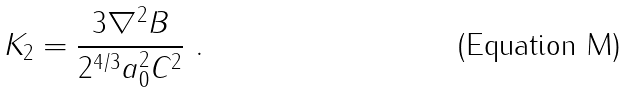Convert formula to latex. <formula><loc_0><loc_0><loc_500><loc_500>K _ { 2 } = \frac { 3 \nabla ^ { 2 } B } { 2 ^ { 4 / 3 } a _ { 0 } ^ { 2 } C ^ { 2 } } \ .</formula> 